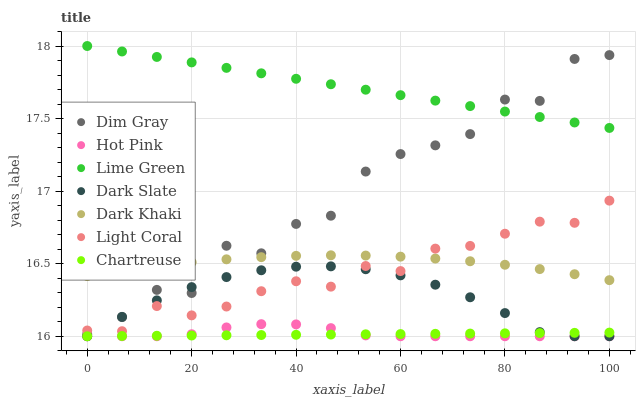Does Chartreuse have the minimum area under the curve?
Answer yes or no. Yes. Does Lime Green have the maximum area under the curve?
Answer yes or no. Yes. Does Dim Gray have the minimum area under the curve?
Answer yes or no. No. Does Dim Gray have the maximum area under the curve?
Answer yes or no. No. Is Chartreuse the smoothest?
Answer yes or no. Yes. Is Dim Gray the roughest?
Answer yes or no. Yes. Is Hot Pink the smoothest?
Answer yes or no. No. Is Hot Pink the roughest?
Answer yes or no. No. Does Hot Pink have the lowest value?
Answer yes or no. Yes. Does Dim Gray have the lowest value?
Answer yes or no. No. Does Lime Green have the highest value?
Answer yes or no. Yes. Does Dim Gray have the highest value?
Answer yes or no. No. Is Hot Pink less than Light Coral?
Answer yes or no. Yes. Is Lime Green greater than Dark Khaki?
Answer yes or no. Yes. Does Dark Khaki intersect Dim Gray?
Answer yes or no. Yes. Is Dark Khaki less than Dim Gray?
Answer yes or no. No. Is Dark Khaki greater than Dim Gray?
Answer yes or no. No. Does Hot Pink intersect Light Coral?
Answer yes or no. No. 